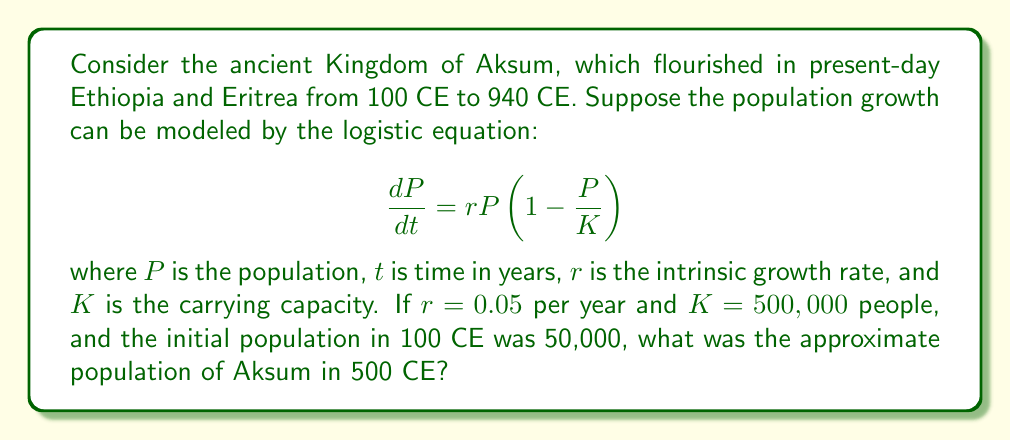Can you answer this question? To solve this problem, we need to use the solution to the logistic equation:

$$P(t) = \frac{K}{1 + \left(\frac{K}{P_0} - 1\right)e^{-rt}}$$

Where:
$P(t)$ is the population at time $t$
$K = 500,000$ (carrying capacity)
$P_0 = 50,000$ (initial population)
$r = 0.05$ (intrinsic growth rate)
$t = 400$ (time elapsed from 100 CE to 500 CE)

Let's substitute these values into the equation:

$$P(400) = \frac{500,000}{1 + \left(\frac{500,000}{50,000} - 1\right)e^{-0.05 \cdot 400}}$$

$$= \frac{500,000}{1 + (10 - 1)e^{-20}}$$

$$= \frac{500,000}{1 + 9e^{-20}}$$

Now, let's calculate $e^{-20}$:

$e^{-20} \approx 2.061 \times 10^{-9}$

Substituting this back:

$$P(400) = \frac{500,000}{1 + 9 \cdot (2.061 \times 10^{-9})}$$

$$\approx \frac{500,000}{1.000000019}$$

$$\approx 499,999.99$$

Rounding to the nearest whole number, we get 500,000.
Answer: 500,000 people 